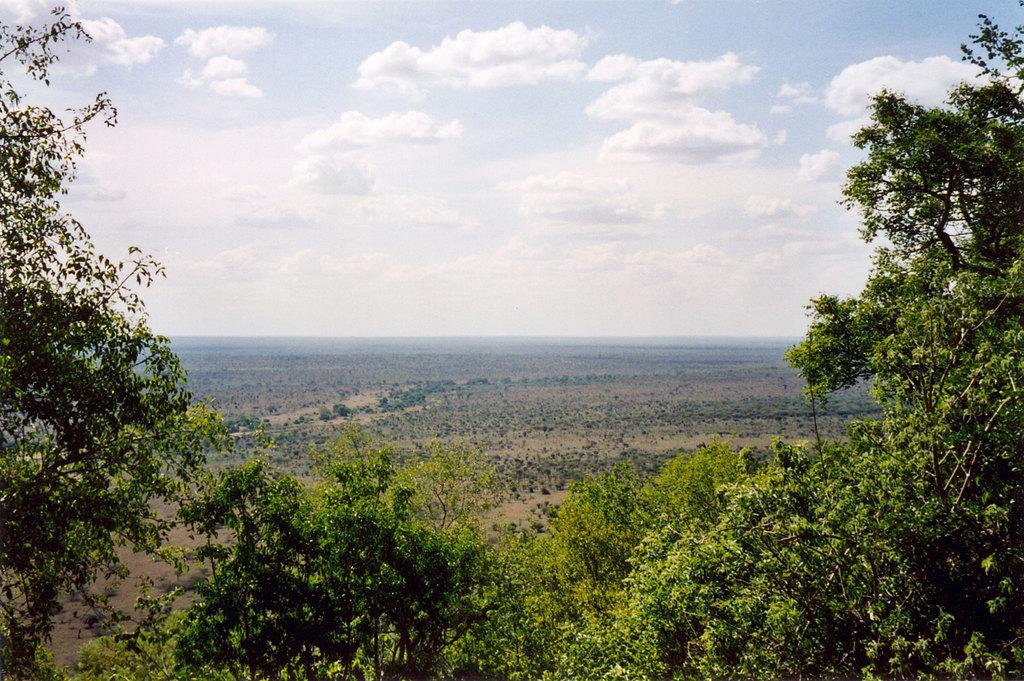What type of landscape is depicted in the image? The image features farmland. What natural elements can be seen in the image? There are trees, plants, grass, and open land visible in the image. What is visible at the top of the image? The sky is visible at the top of the image. What can be observed in the sky? Clouds are present in the sky. What type of leather is being used to print the fall season on the trees in the image? There is no leather or printing present in the image; it features natural elements such as trees and plants. 